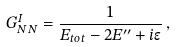<formula> <loc_0><loc_0><loc_500><loc_500>G _ { N N } ^ { I } = \frac { 1 } { E _ { t o t } - 2 E ^ { \prime \prime } + i \epsilon } \, ,</formula> 